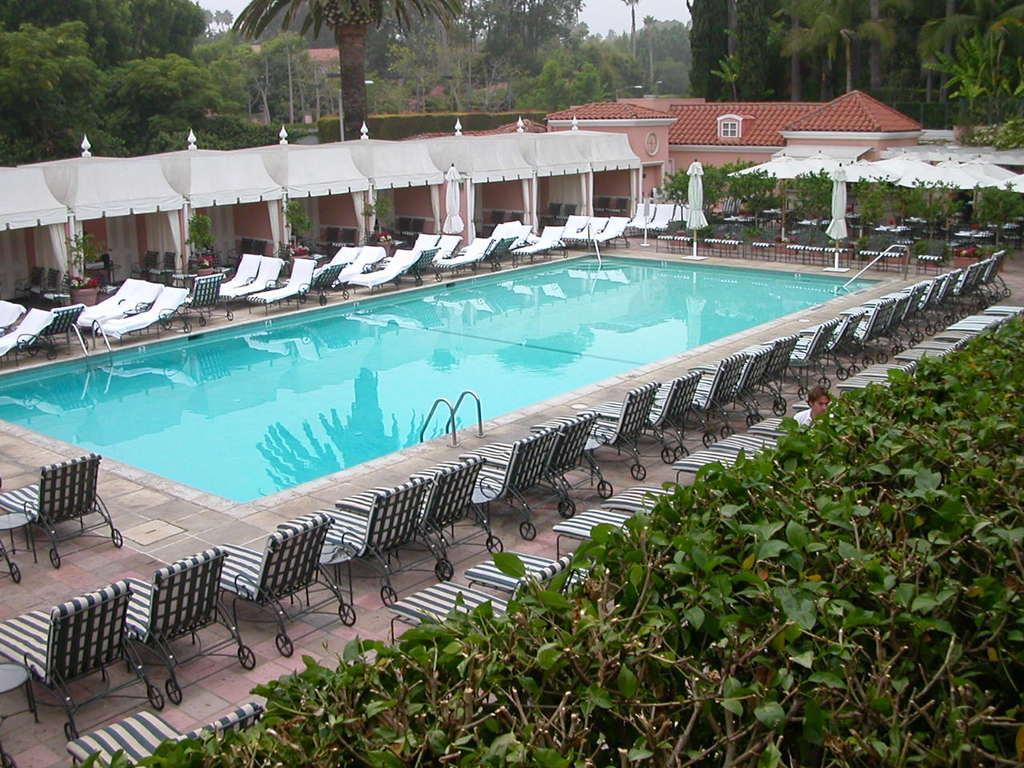Describe this image in one or two sentences. In this image I can see a swimming pool ,around the pool I can see chairs and bushes house and at the top I can see the sky 